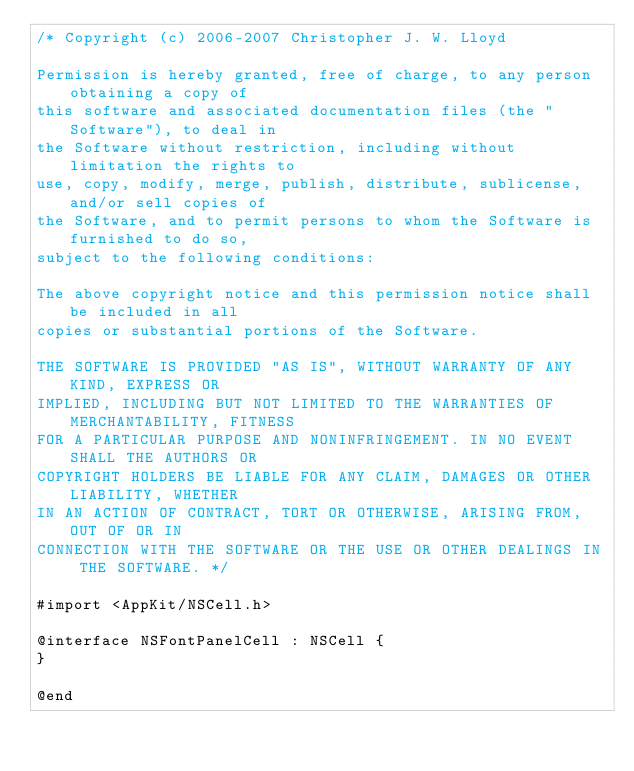Convert code to text. <code><loc_0><loc_0><loc_500><loc_500><_C_>/* Copyright (c) 2006-2007 Christopher J. W. Lloyd

Permission is hereby granted, free of charge, to any person obtaining a copy of
this software and associated documentation files (the "Software"), to deal in
the Software without restriction, including without limitation the rights to
use, copy, modify, merge, publish, distribute, sublicense, and/or sell copies of
the Software, and to permit persons to whom the Software is furnished to do so,
subject to the following conditions:

The above copyright notice and this permission notice shall be included in all
copies or substantial portions of the Software.

THE SOFTWARE IS PROVIDED "AS IS", WITHOUT WARRANTY OF ANY KIND, EXPRESS OR
IMPLIED, INCLUDING BUT NOT LIMITED TO THE WARRANTIES OF MERCHANTABILITY, FITNESS
FOR A PARTICULAR PURPOSE AND NONINFRINGEMENT. IN NO EVENT SHALL THE AUTHORS OR
COPYRIGHT HOLDERS BE LIABLE FOR ANY CLAIM, DAMAGES OR OTHER LIABILITY, WHETHER
IN AN ACTION OF CONTRACT, TORT OR OTHERWISE, ARISING FROM, OUT OF OR IN
CONNECTION WITH THE SOFTWARE OR THE USE OR OTHER DEALINGS IN THE SOFTWARE. */

#import <AppKit/NSCell.h>

@interface NSFontPanelCell : NSCell {
}

@end
</code> 